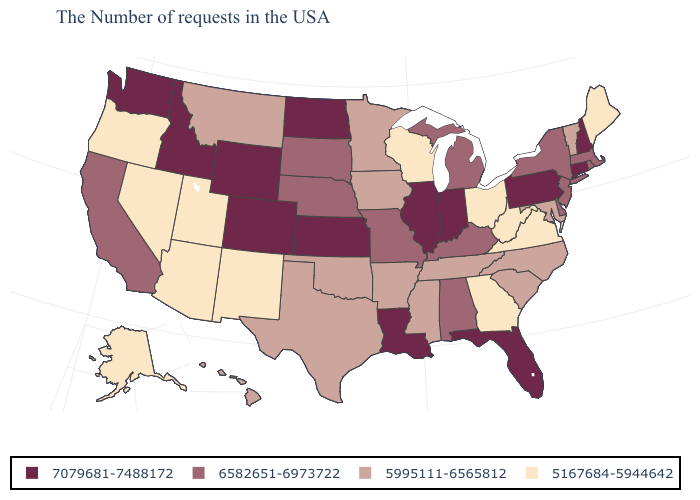Which states have the highest value in the USA?
Write a very short answer. New Hampshire, Connecticut, Pennsylvania, Florida, Indiana, Illinois, Louisiana, Kansas, North Dakota, Wyoming, Colorado, Idaho, Washington. Among the states that border South Carolina , which have the lowest value?
Short answer required. Georgia. Among the states that border Oklahoma , does Texas have the highest value?
Be succinct. No. Is the legend a continuous bar?
Short answer required. No. What is the value of Utah?
Write a very short answer. 5167684-5944642. Name the states that have a value in the range 5995111-6565812?
Keep it brief. Vermont, Maryland, North Carolina, South Carolina, Tennessee, Mississippi, Arkansas, Minnesota, Iowa, Oklahoma, Texas, Montana, Hawaii. Does Massachusetts have the lowest value in the USA?
Concise answer only. No. Does the map have missing data?
Write a very short answer. No. Among the states that border New Jersey , which have the highest value?
Concise answer only. Pennsylvania. Name the states that have a value in the range 5167684-5944642?
Short answer required. Maine, Virginia, West Virginia, Ohio, Georgia, Wisconsin, New Mexico, Utah, Arizona, Nevada, Oregon, Alaska. What is the value of Mississippi?
Be succinct. 5995111-6565812. Name the states that have a value in the range 6582651-6973722?
Concise answer only. Massachusetts, Rhode Island, New York, New Jersey, Delaware, Michigan, Kentucky, Alabama, Missouri, Nebraska, South Dakota, California. Which states have the lowest value in the West?
Concise answer only. New Mexico, Utah, Arizona, Nevada, Oregon, Alaska. What is the value of Colorado?
Short answer required. 7079681-7488172. What is the lowest value in states that border Alabama?
Short answer required. 5167684-5944642. 